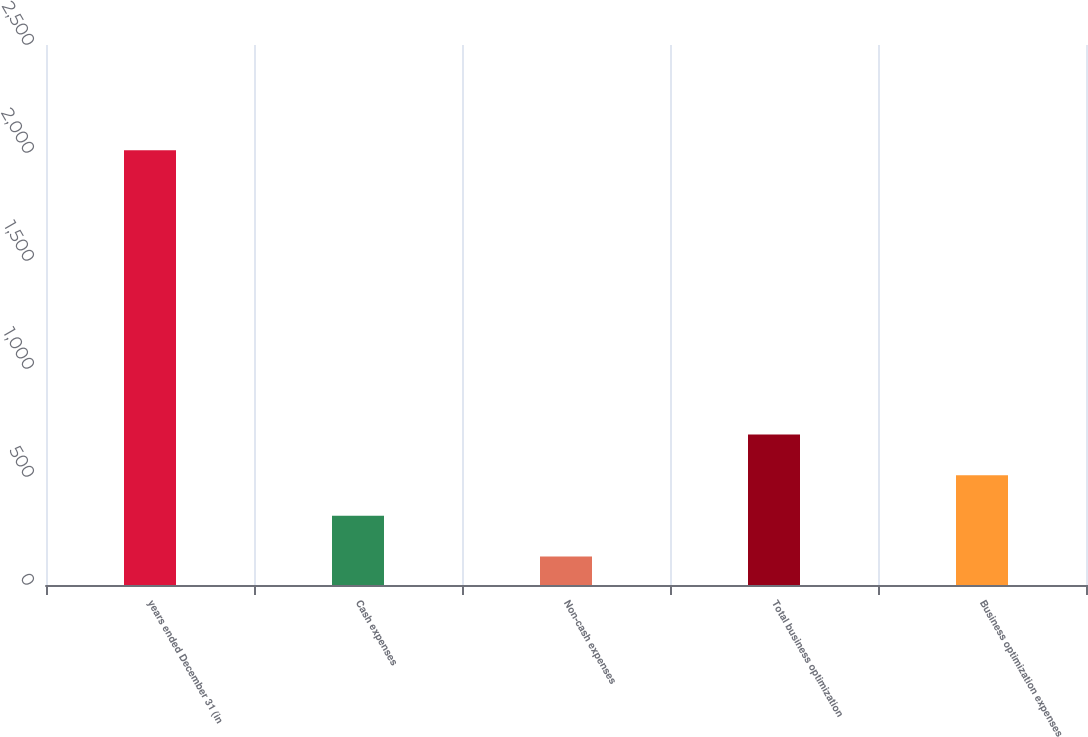Convert chart to OTSL. <chart><loc_0><loc_0><loc_500><loc_500><bar_chart><fcel>years ended December 31 (in<fcel>Cash expenses<fcel>Non-cash expenses<fcel>Total business optimization<fcel>Business optimization expenses<nl><fcel>2013<fcel>320.1<fcel>132<fcel>696.3<fcel>508.2<nl></chart> 